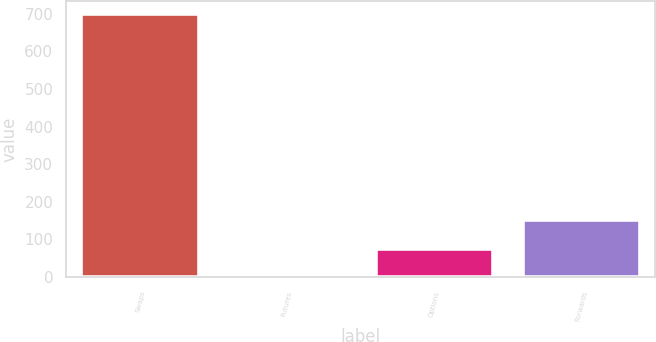Convert chart. <chart><loc_0><loc_0><loc_500><loc_500><bar_chart><fcel>Swaps<fcel>Futures<fcel>Options<fcel>Forwards<nl><fcel>698<fcel>4<fcel>73.4<fcel>152<nl></chart> 